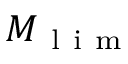Convert formula to latex. <formula><loc_0><loc_0><loc_500><loc_500>M _ { l i m }</formula> 